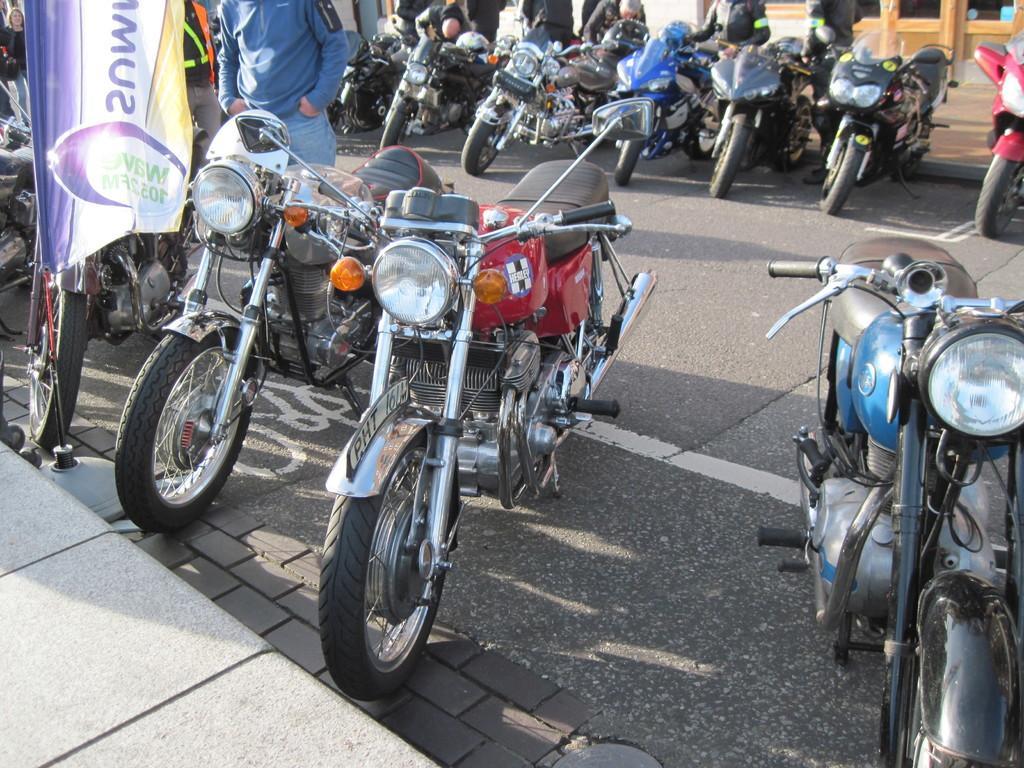In one or two sentences, can you explain what this image depicts? In the center of the picture there are bikes and people, on the road. At the bottom it is footpath. 